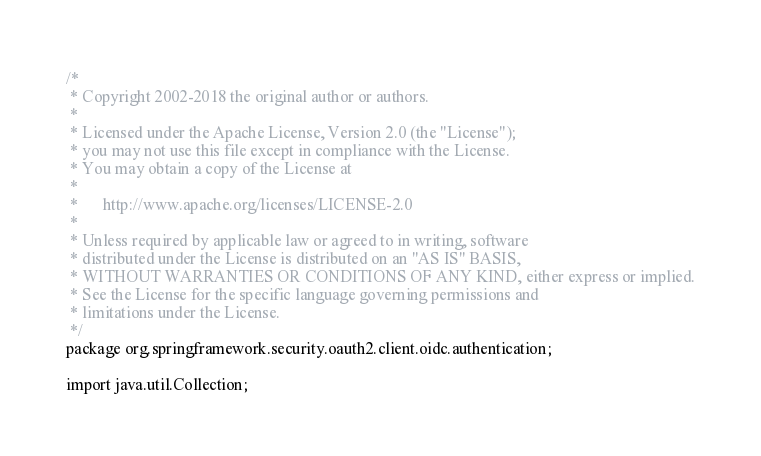<code> <loc_0><loc_0><loc_500><loc_500><_Java_>/*
 * Copyright 2002-2018 the original author or authors.
 *
 * Licensed under the Apache License, Version 2.0 (the "License");
 * you may not use this file except in compliance with the License.
 * You may obtain a copy of the License at
 *
 *      http://www.apache.org/licenses/LICENSE-2.0
 *
 * Unless required by applicable law or agreed to in writing, software
 * distributed under the License is distributed on an "AS IS" BASIS,
 * WITHOUT WARRANTIES OR CONDITIONS OF ANY KIND, either express or implied.
 * See the License for the specific language governing permissions and
 * limitations under the License.
 */
package org.springframework.security.oauth2.client.oidc.authentication;

import java.util.Collection;</code> 